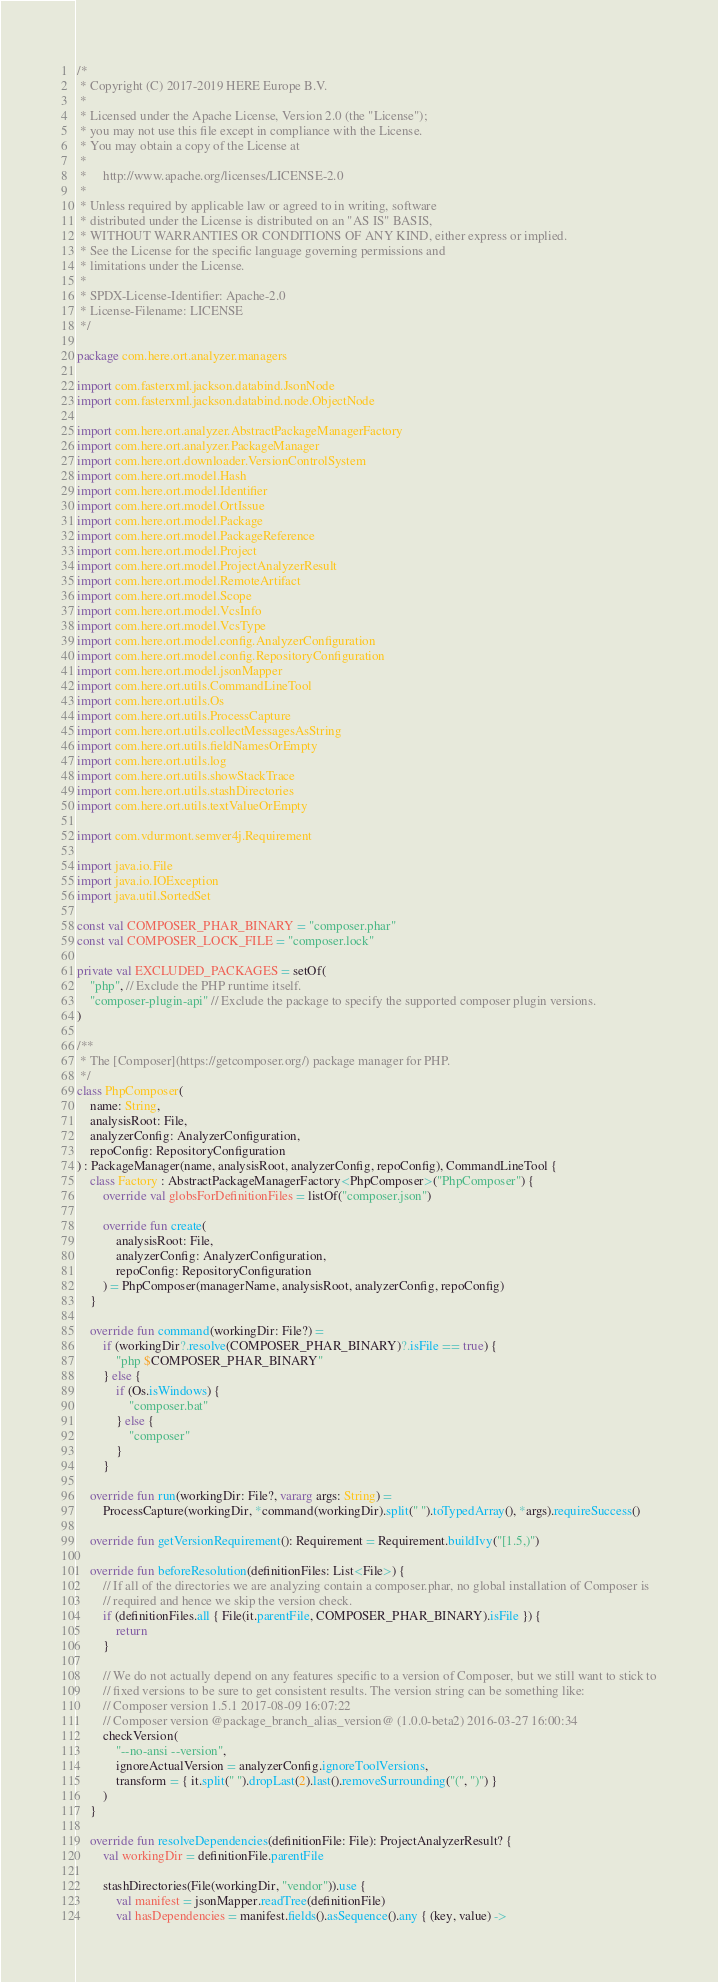Convert code to text. <code><loc_0><loc_0><loc_500><loc_500><_Kotlin_>/*
 * Copyright (C) 2017-2019 HERE Europe B.V.
 *
 * Licensed under the Apache License, Version 2.0 (the "License");
 * you may not use this file except in compliance with the License.
 * You may obtain a copy of the License at
 *
 *     http://www.apache.org/licenses/LICENSE-2.0
 *
 * Unless required by applicable law or agreed to in writing, software
 * distributed under the License is distributed on an "AS IS" BASIS,
 * WITHOUT WARRANTIES OR CONDITIONS OF ANY KIND, either express or implied.
 * See the License for the specific language governing permissions and
 * limitations under the License.
 *
 * SPDX-License-Identifier: Apache-2.0
 * License-Filename: LICENSE
 */

package com.here.ort.analyzer.managers

import com.fasterxml.jackson.databind.JsonNode
import com.fasterxml.jackson.databind.node.ObjectNode

import com.here.ort.analyzer.AbstractPackageManagerFactory
import com.here.ort.analyzer.PackageManager
import com.here.ort.downloader.VersionControlSystem
import com.here.ort.model.Hash
import com.here.ort.model.Identifier
import com.here.ort.model.OrtIssue
import com.here.ort.model.Package
import com.here.ort.model.PackageReference
import com.here.ort.model.Project
import com.here.ort.model.ProjectAnalyzerResult
import com.here.ort.model.RemoteArtifact
import com.here.ort.model.Scope
import com.here.ort.model.VcsInfo
import com.here.ort.model.VcsType
import com.here.ort.model.config.AnalyzerConfiguration
import com.here.ort.model.config.RepositoryConfiguration
import com.here.ort.model.jsonMapper
import com.here.ort.utils.CommandLineTool
import com.here.ort.utils.Os
import com.here.ort.utils.ProcessCapture
import com.here.ort.utils.collectMessagesAsString
import com.here.ort.utils.fieldNamesOrEmpty
import com.here.ort.utils.log
import com.here.ort.utils.showStackTrace
import com.here.ort.utils.stashDirectories
import com.here.ort.utils.textValueOrEmpty

import com.vdurmont.semver4j.Requirement

import java.io.File
import java.io.IOException
import java.util.SortedSet

const val COMPOSER_PHAR_BINARY = "composer.phar"
const val COMPOSER_LOCK_FILE = "composer.lock"

private val EXCLUDED_PACKAGES = setOf(
    "php", // Exclude the PHP runtime itself.
    "composer-plugin-api" // Exclude the package to specify the supported composer plugin versions.
)

/**
 * The [Composer](https://getcomposer.org/) package manager for PHP.
 */
class PhpComposer(
    name: String,
    analysisRoot: File,
    analyzerConfig: AnalyzerConfiguration,
    repoConfig: RepositoryConfiguration
) : PackageManager(name, analysisRoot, analyzerConfig, repoConfig), CommandLineTool {
    class Factory : AbstractPackageManagerFactory<PhpComposer>("PhpComposer") {
        override val globsForDefinitionFiles = listOf("composer.json")

        override fun create(
            analysisRoot: File,
            analyzerConfig: AnalyzerConfiguration,
            repoConfig: RepositoryConfiguration
        ) = PhpComposer(managerName, analysisRoot, analyzerConfig, repoConfig)
    }

    override fun command(workingDir: File?) =
        if (workingDir?.resolve(COMPOSER_PHAR_BINARY)?.isFile == true) {
            "php $COMPOSER_PHAR_BINARY"
        } else {
            if (Os.isWindows) {
                "composer.bat"
            } else {
                "composer"
            }
        }

    override fun run(workingDir: File?, vararg args: String) =
        ProcessCapture(workingDir, *command(workingDir).split(" ").toTypedArray(), *args).requireSuccess()

    override fun getVersionRequirement(): Requirement = Requirement.buildIvy("[1.5,)")

    override fun beforeResolution(definitionFiles: List<File>) {
        // If all of the directories we are analyzing contain a composer.phar, no global installation of Composer is
        // required and hence we skip the version check.
        if (definitionFiles.all { File(it.parentFile, COMPOSER_PHAR_BINARY).isFile }) {
            return
        }

        // We do not actually depend on any features specific to a version of Composer, but we still want to stick to
        // fixed versions to be sure to get consistent results. The version string can be something like:
        // Composer version 1.5.1 2017-08-09 16:07:22
        // Composer version @package_branch_alias_version@ (1.0.0-beta2) 2016-03-27 16:00:34
        checkVersion(
            "--no-ansi --version",
            ignoreActualVersion = analyzerConfig.ignoreToolVersions,
            transform = { it.split(" ").dropLast(2).last().removeSurrounding("(", ")") }
        )
    }

    override fun resolveDependencies(definitionFile: File): ProjectAnalyzerResult? {
        val workingDir = definitionFile.parentFile

        stashDirectories(File(workingDir, "vendor")).use {
            val manifest = jsonMapper.readTree(definitionFile)
            val hasDependencies = manifest.fields().asSequence().any { (key, value) -></code> 